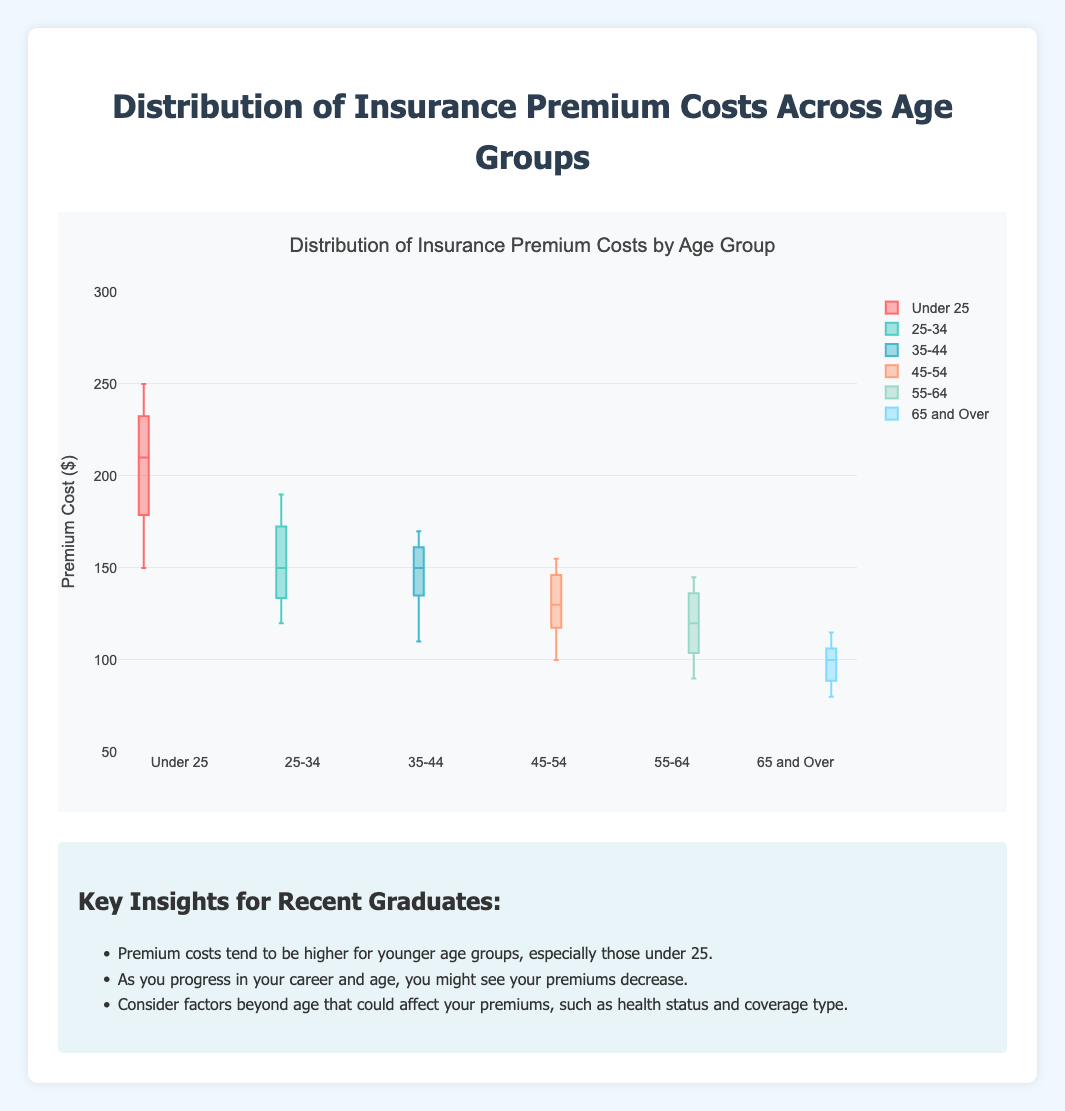What is the title of the figure? The title can be found at the top of the figure. In this case, it reads "Distribution of Insurance Premium Costs by Age Group".
Answer: Distribution of Insurance Premium Costs by Age Group What is the range of premium costs displayed on the y-axis? The y-axis indicates the range of premium costs, extending from 50 to 300 dollars. This range includes the values represented by the box plots.
Answer: 50 to 300 dollars Which age group has the highest median premium cost? By inspecting the box plots, we see that the median line (the middle line within each box) is highest for the "Under 25" age group.
Answer: Under 25 What is the interquartile range (IQR) of premium costs for the 25-34 age group? The IQR is calculated as the difference between the third quartile (Q3) and the first quartile (Q1). For the 25-34 age group, Q3 is around 180 and Q1 is around 130, so the IQR is 180 - 130.
Answer: 50 dollars How do the premium costs for the 65 and Over age group compare to those of the Under 25 age group? Comparisons can be made by looking at the median, the spread of the data, and the range. The 65 and Over age group has a lower median, smaller interquartile range, and generally lower premiums compared to the Under 25 age group.
Answer: Lower overall Which age group has the smallest interquartile range (IQR) and what is it? The IQR is the difference between the third quartile (Q3) and the first quartile (Q1). The smallest IQR appears in the 65 and Over age group, approximately between 85 and 105, so IQR is around 20 dollars.
Answer: 65 and Over, 20 dollars Are there any age groups with outliers and if so, which ones? Outliers are marked as individual points outside the whiskers (top and bottom lines extending from the box). The Under 25 and 65 and Over age groups show some outlier points in this plot.
Answer: Under 25 and 65 and Over What is the median premium cost for the 45-54 age group? The median is indicated by the line within the box for the 45-54 age group. It is positioned at approximately 130 dollars.
Answer: 130 dollars Which age group shows the most variability in premium costs? The most variability is indicated by the largest spread between the whiskers and the presence of outliers. The Under 25 age group shows the most variability in premium costs.
Answer: Under 25 How do the premium costs trend as the age groups increase? Observing the progression of the medians and the position of the boxes, we can see that premium costs generally decrease as age groups increase, with the highest costs in the youngest age group (Under 25) and the lowest in the oldest group (65 and Over).
Answer: Decrease 